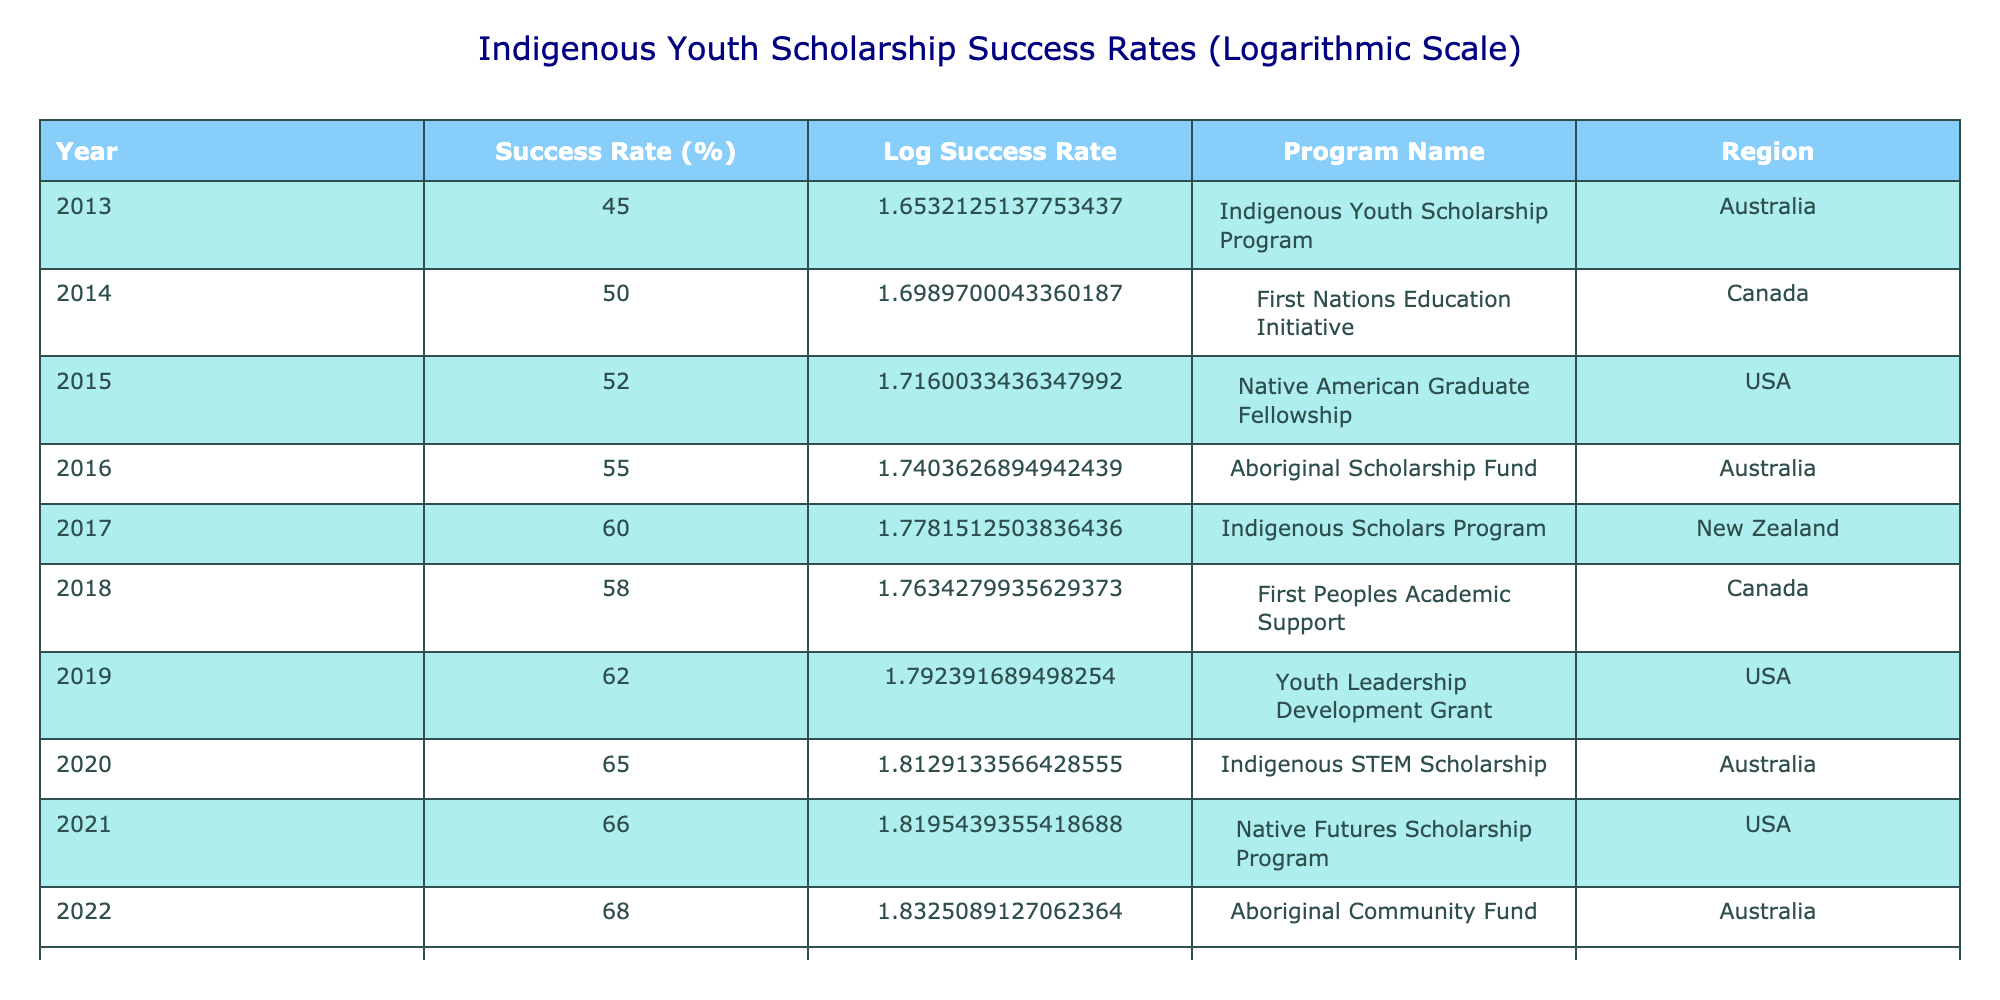What was the success rate of indigenous youth scholarship programs in 2013? The table shows a success rate of 45% for the year 2013 under the Indigenous Youth Scholarship Program in Australia.
Answer: 45% Which program had the highest success rate, and what was that rate? The Indigenous Empowerment Grant in Canada had the highest success rate of 70% in 2023.
Answer: 70% Is it true that the success rate for the Aboriginal Scholarship Fund in Australia exceeded 50%? The Aboriginal Scholarship Fund had a success rate of 55% in 2016, which is more than 50%, so the statement is true.
Answer: Yes What is the difference in success rates between the First Nations Education Initiative in Canada (2014) and the Indigenous Scholars Program in New Zealand (2017)? The success rate of the First Nations Education Initiative in 2014 was 50%, and for the Indigenous Scholars Program in 2017, it was 60%. The difference is 60% - 50% = 10%.
Answer: 10% What was the average success rate of indigenous youth scholarship programs from 2013 to 2023? To find the average, we sum all success rates from the years listed: (45 + 50 + 52 + 55 + 60 + 58 + 62 + 65 + 66 + 68 + 70) = 682. There are 11 programs, so the average is 682 / 11 = approximately 62. \
Answer: 62 Which region had the program with the second highest success rate? The second highest success rate was 68% in the Aboriginal Community Fund, which is in Australia.
Answer: Australia Did the success rate increase every year from 2013 to 2023? Looking at the table, the success rates consistently increased each year, indicating that the rates did indeed rise every year.
Answer: Yes In which year did the success rate first exceed 60%? The success rate first exceeded 60% in 2017 when the Indigenous Scholars Program achieved a success rate of 60%.
Answer: 2017 What program had a success rate decrease compared to the previous year? The First Peoples Academic Support program in 2018 had a success rate of 58%, which is a decrease from 60% in 2017, indicating a decline.
Answer: First Peoples Academic Support Program 